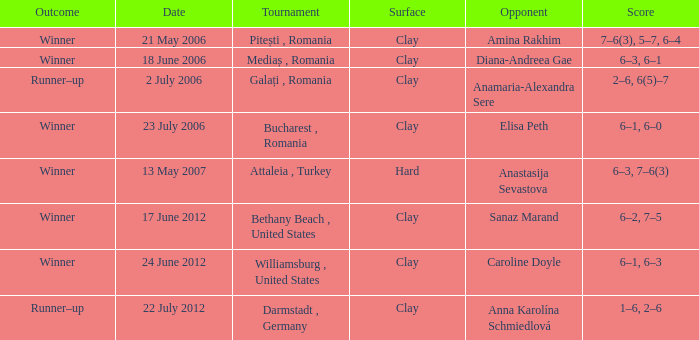What contest was conducted on 21 may 2006? Pitești , Romania. 